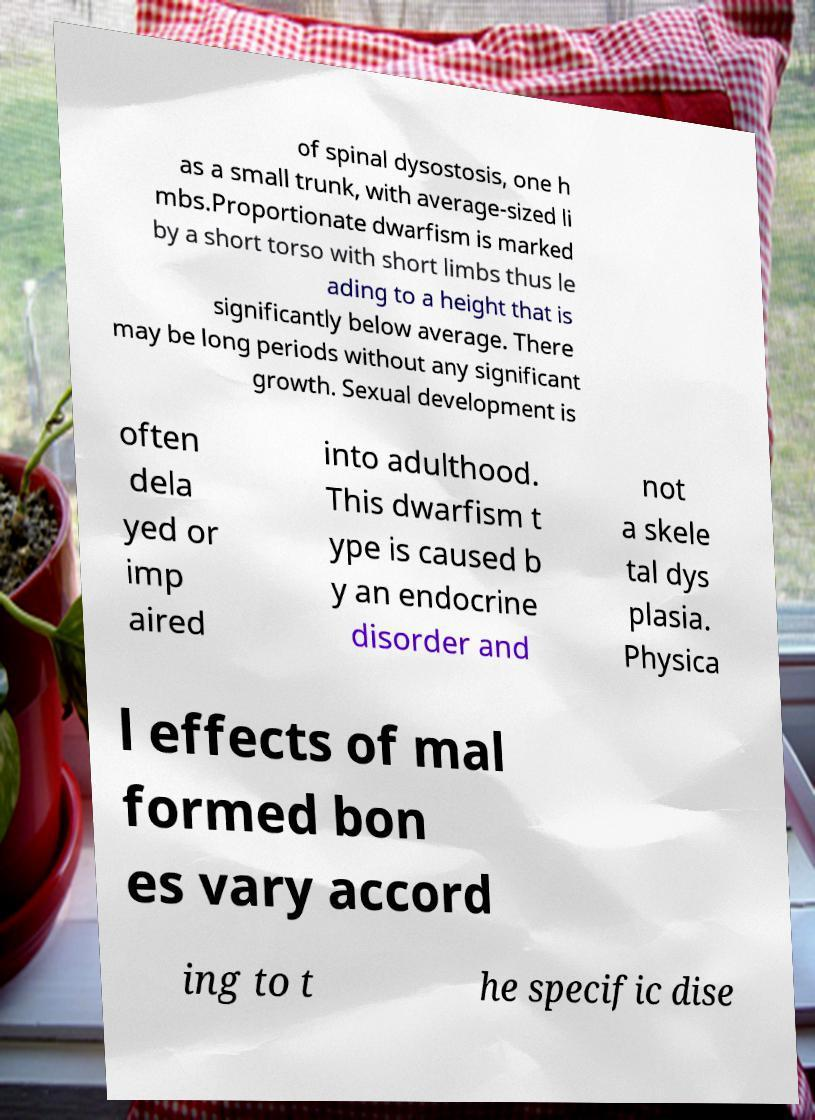What messages or text are displayed in this image? I need them in a readable, typed format. of spinal dysostosis, one h as a small trunk, with average-sized li mbs.Proportionate dwarfism is marked by a short torso with short limbs thus le ading to a height that is significantly below average. There may be long periods without any significant growth. Sexual development is often dela yed or imp aired into adulthood. This dwarfism t ype is caused b y an endocrine disorder and not a skele tal dys plasia. Physica l effects of mal formed bon es vary accord ing to t he specific dise 